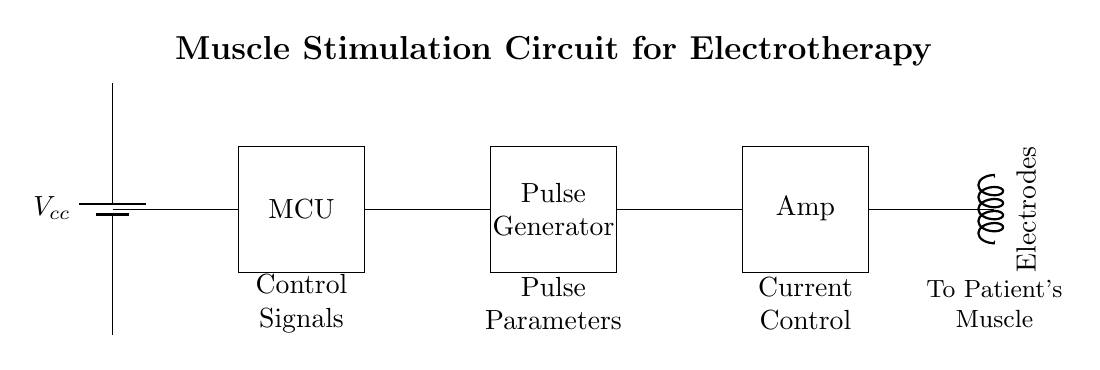What is the power supply used in this circuit? The power supply in the circuit is indicated by the battery component labeled Vcc. It provides the necessary voltage for the circuit's operation.
Answer: Vcc What is the role of the microcontroller in this circuit? The microcontroller (MCU) acts as the central control unit, where it processes input signals and generates control signals for the pulse generator.
Answer: Control unit What does the pulse generator do in this circuit? The pulse generator produces electrical pulses that stimulate the muscles through the electrodes, based on parameters defined by the microcontroller.
Answer: Generates pulses Which component controls the current in this circuit? The component labeled "Amp" (Amplifier) is responsible for controlling the amount of current flowing to the electrodes, ensuring proper stimulation of the muscles.
Answer: Amp How are the electrodes connected in this circuit? The electrodes are connected to the output of the amplifier, allowing the generated stimulation pulses to be delivered to the patient's muscle.
Answer: To the amplifier What is the expected signal flow direction in this circuit? The expected signal flow begins from the power supply, moves through the microcontroller, pulse generator, amplifier, and finally to the electrodes.
Answer: Power supply to electrodes Which component would you adjust to change pulse parameters? The pulse parameters can be adjusted directly in the pulse generator, where settings for frequency, duration, and intensity of the stimulation pulses are configured.
Answer: Pulse generator 